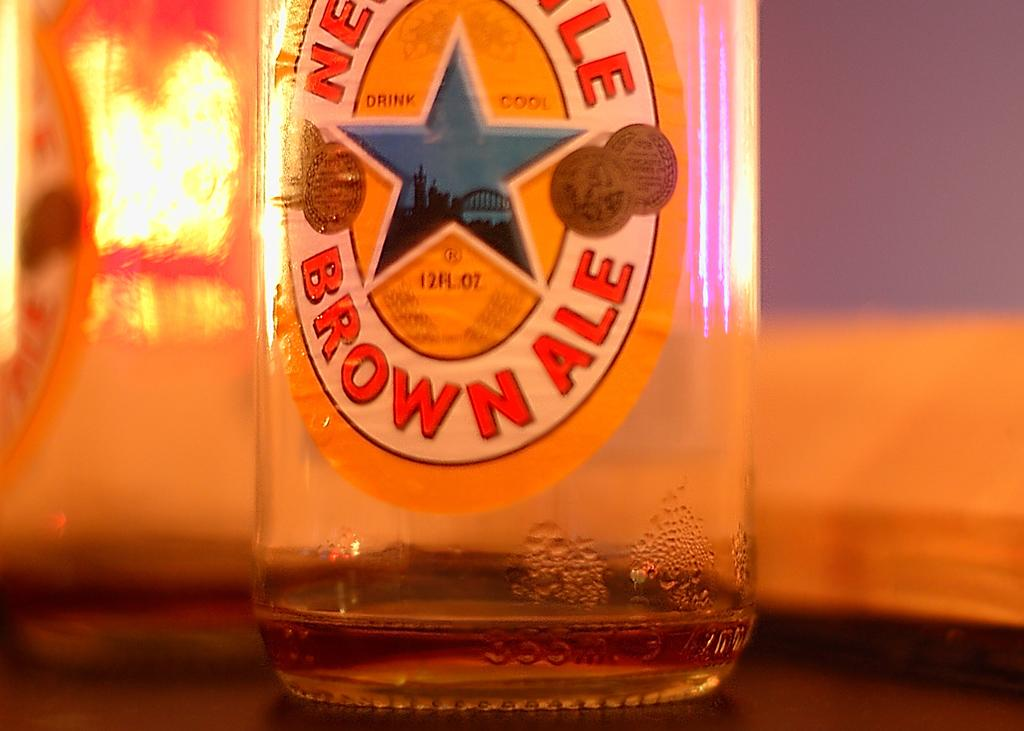<image>
Render a clear and concise summary of the photo. Brown Ale 12 fl oz bottle with a star label on it 